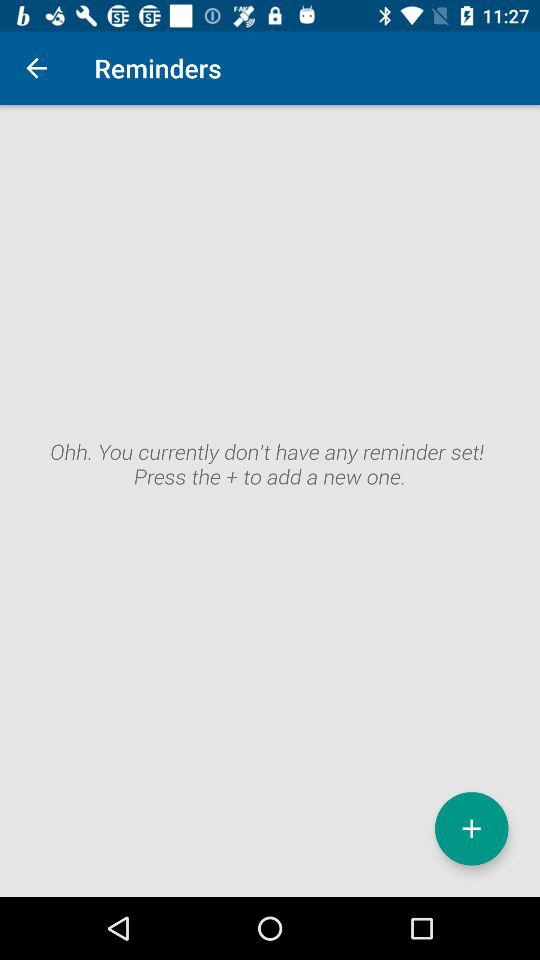How many reminders are there?
Answer the question using a single word or phrase. 0 